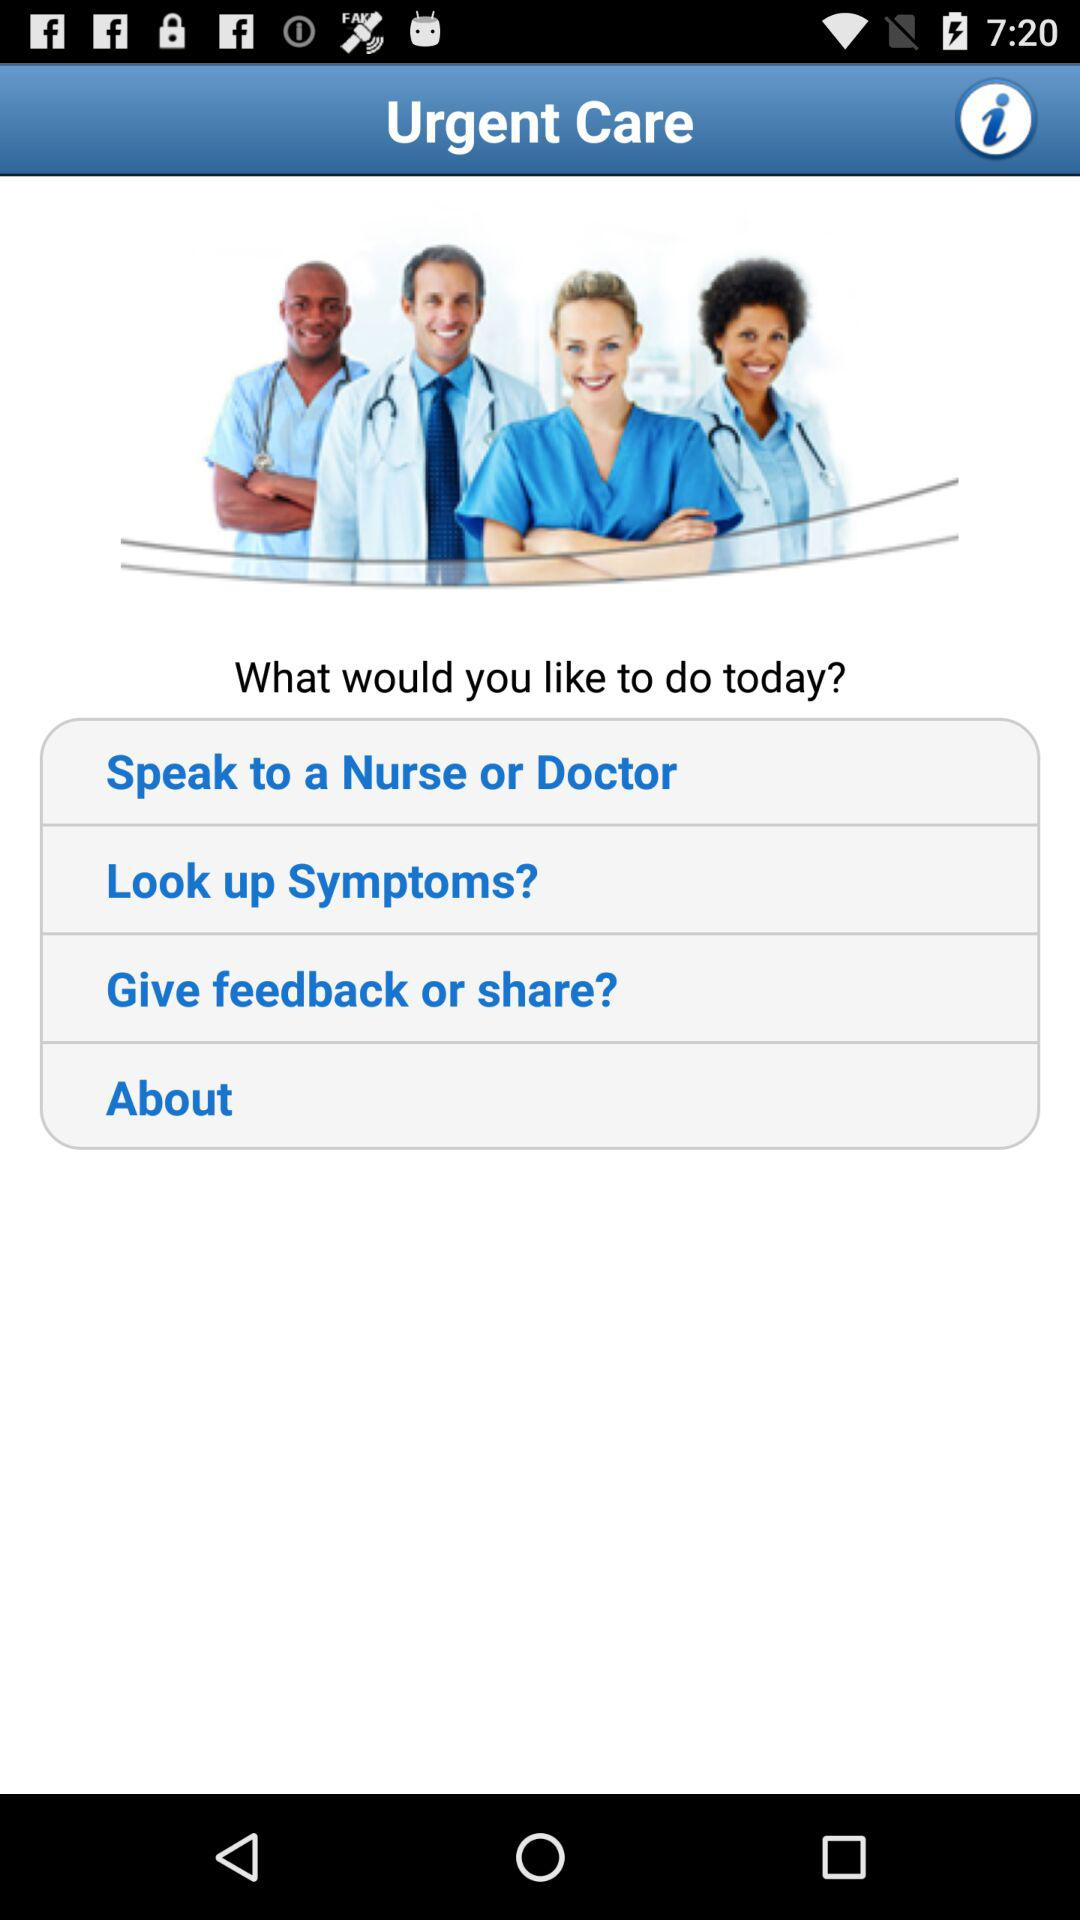What are the available options? The available options are "Speak to a Nurse or Doctor", "Look up Symptoms?", "Give feedback or share?" and "About". 